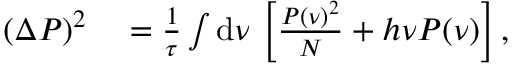Convert formula to latex. <formula><loc_0><loc_0><loc_500><loc_500>\begin{array} { r l } { ( \Delta P ) ^ { 2 } } & = \frac { 1 } { \tau } \int d \nu \, \left [ \frac { P ( \nu ) ^ { 2 } } { N } + h \nu P ( \nu ) \right ] , } \end{array}</formula> 